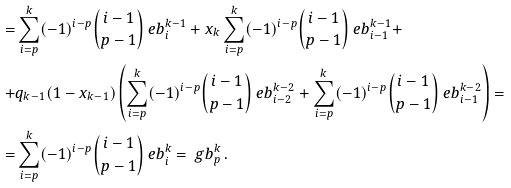Convert formula to latex. <formula><loc_0><loc_0><loc_500><loc_500>= & \sum _ { i = p } ^ { k } ( - 1 ) ^ { i - p } \binom { i - 1 } { p - 1 } \ e b _ { i } ^ { k - 1 } + x _ { k } \sum _ { i = p } ^ { k } ( - 1 ) ^ { i - p } \binom { i - 1 } { p - 1 } \ e b _ { i - 1 } ^ { k - 1 } + \\ + & q _ { k - 1 } ( 1 - x _ { k - 1 } ) \left ( \sum _ { i = p } ^ { k } ( - 1 ) ^ { i - p } \binom { i - 1 } { p - 1 } \ e b _ { i - 2 } ^ { k - 2 } + \sum _ { i = p } ^ { k } ( - 1 ) ^ { i - p } \binom { i - 1 } { p - 1 } \ e b _ { i - 1 } ^ { k - 2 } \right ) = \\ = & \sum _ { i = p } ^ { k } ( - 1 ) ^ { i - p } \binom { i - 1 } { p - 1 } \ e b _ { i } ^ { k } = \ g b _ { p } ^ { k } \, .</formula> 